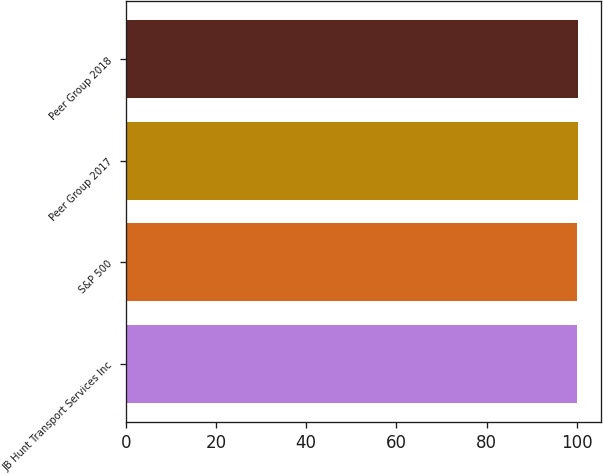Convert chart. <chart><loc_0><loc_0><loc_500><loc_500><bar_chart><fcel>JB Hunt Transport Services Inc<fcel>S&P 500<fcel>Peer Group 2017<fcel>Peer Group 2018<nl><fcel>100<fcel>100.1<fcel>100.2<fcel>100.3<nl></chart> 